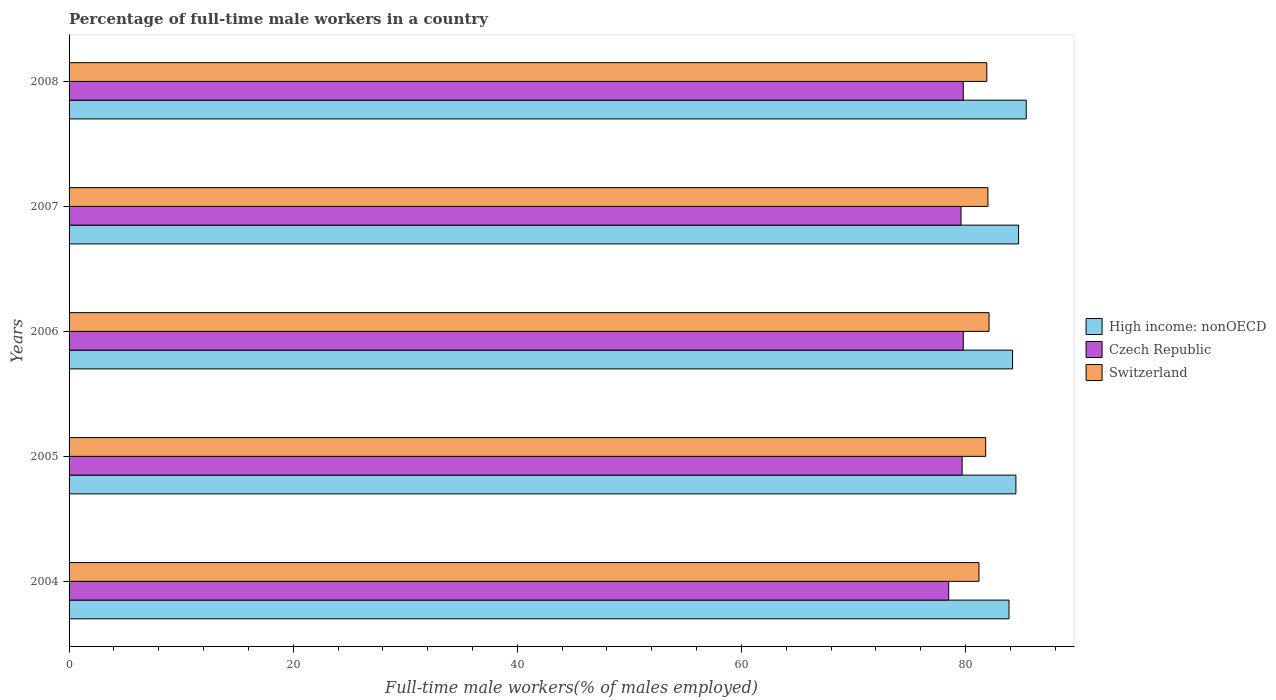How many different coloured bars are there?
Keep it short and to the point. 3. How many bars are there on the 4th tick from the top?
Your answer should be compact. 3. In how many cases, is the number of bars for a given year not equal to the number of legend labels?
Your answer should be very brief. 0. What is the percentage of full-time male workers in High income: nonOECD in 2005?
Your response must be concise. 84.5. Across all years, what is the maximum percentage of full-time male workers in High income: nonOECD?
Offer a very short reply. 85.42. Across all years, what is the minimum percentage of full-time male workers in Czech Republic?
Your response must be concise. 78.5. What is the total percentage of full-time male workers in Czech Republic in the graph?
Your answer should be compact. 397.4. What is the difference between the percentage of full-time male workers in High income: nonOECD in 2006 and that in 2007?
Provide a succinct answer. -0.54. What is the difference between the percentage of full-time male workers in High income: nonOECD in 2004 and the percentage of full-time male workers in Czech Republic in 2008?
Your answer should be very brief. 4.08. What is the average percentage of full-time male workers in Czech Republic per year?
Make the answer very short. 79.48. In the year 2004, what is the difference between the percentage of full-time male workers in Czech Republic and percentage of full-time male workers in High income: nonOECD?
Your answer should be compact. -5.38. In how many years, is the percentage of full-time male workers in Switzerland greater than 72 %?
Your response must be concise. 5. What is the ratio of the percentage of full-time male workers in Switzerland in 2004 to that in 2006?
Keep it short and to the point. 0.99. Is the difference between the percentage of full-time male workers in Czech Republic in 2004 and 2008 greater than the difference between the percentage of full-time male workers in High income: nonOECD in 2004 and 2008?
Give a very brief answer. Yes. What is the difference between the highest and the second highest percentage of full-time male workers in Switzerland?
Offer a terse response. 0.1. What is the difference between the highest and the lowest percentage of full-time male workers in Czech Republic?
Provide a short and direct response. 1.3. In how many years, is the percentage of full-time male workers in High income: nonOECD greater than the average percentage of full-time male workers in High income: nonOECD taken over all years?
Offer a terse response. 2. Is the sum of the percentage of full-time male workers in Czech Republic in 2004 and 2006 greater than the maximum percentage of full-time male workers in Switzerland across all years?
Provide a short and direct response. Yes. What does the 3rd bar from the top in 2005 represents?
Offer a terse response. High income: nonOECD. What does the 2nd bar from the bottom in 2005 represents?
Keep it short and to the point. Czech Republic. How many bars are there?
Provide a short and direct response. 15. What is the difference between two consecutive major ticks on the X-axis?
Your answer should be very brief. 20. Does the graph contain grids?
Offer a very short reply. No. Where does the legend appear in the graph?
Ensure brevity in your answer.  Center right. How are the legend labels stacked?
Provide a short and direct response. Vertical. What is the title of the graph?
Your answer should be very brief. Percentage of full-time male workers in a country. Does "Oman" appear as one of the legend labels in the graph?
Offer a terse response. No. What is the label or title of the X-axis?
Make the answer very short. Full-time male workers(% of males employed). What is the Full-time male workers(% of males employed) of High income: nonOECD in 2004?
Give a very brief answer. 83.88. What is the Full-time male workers(% of males employed) of Czech Republic in 2004?
Your answer should be compact. 78.5. What is the Full-time male workers(% of males employed) of Switzerland in 2004?
Offer a very short reply. 81.2. What is the Full-time male workers(% of males employed) in High income: nonOECD in 2005?
Your answer should be very brief. 84.5. What is the Full-time male workers(% of males employed) of Czech Republic in 2005?
Provide a succinct answer. 79.7. What is the Full-time male workers(% of males employed) of Switzerland in 2005?
Your answer should be very brief. 81.8. What is the Full-time male workers(% of males employed) in High income: nonOECD in 2006?
Offer a very short reply. 84.2. What is the Full-time male workers(% of males employed) of Czech Republic in 2006?
Keep it short and to the point. 79.8. What is the Full-time male workers(% of males employed) in Switzerland in 2006?
Keep it short and to the point. 82.1. What is the Full-time male workers(% of males employed) in High income: nonOECD in 2007?
Offer a very short reply. 84.74. What is the Full-time male workers(% of males employed) in Czech Republic in 2007?
Ensure brevity in your answer.  79.6. What is the Full-time male workers(% of males employed) of High income: nonOECD in 2008?
Provide a succinct answer. 85.42. What is the Full-time male workers(% of males employed) in Czech Republic in 2008?
Your response must be concise. 79.8. What is the Full-time male workers(% of males employed) of Switzerland in 2008?
Make the answer very short. 81.9. Across all years, what is the maximum Full-time male workers(% of males employed) in High income: nonOECD?
Ensure brevity in your answer.  85.42. Across all years, what is the maximum Full-time male workers(% of males employed) of Czech Republic?
Offer a very short reply. 79.8. Across all years, what is the maximum Full-time male workers(% of males employed) of Switzerland?
Offer a terse response. 82.1. Across all years, what is the minimum Full-time male workers(% of males employed) of High income: nonOECD?
Give a very brief answer. 83.88. Across all years, what is the minimum Full-time male workers(% of males employed) in Czech Republic?
Ensure brevity in your answer.  78.5. Across all years, what is the minimum Full-time male workers(% of males employed) of Switzerland?
Provide a short and direct response. 81.2. What is the total Full-time male workers(% of males employed) of High income: nonOECD in the graph?
Offer a very short reply. 422.74. What is the total Full-time male workers(% of males employed) in Czech Republic in the graph?
Offer a terse response. 397.4. What is the total Full-time male workers(% of males employed) of Switzerland in the graph?
Keep it short and to the point. 409. What is the difference between the Full-time male workers(% of males employed) of High income: nonOECD in 2004 and that in 2005?
Ensure brevity in your answer.  -0.61. What is the difference between the Full-time male workers(% of males employed) in Czech Republic in 2004 and that in 2005?
Provide a succinct answer. -1.2. What is the difference between the Full-time male workers(% of males employed) in Switzerland in 2004 and that in 2005?
Give a very brief answer. -0.6. What is the difference between the Full-time male workers(% of males employed) of High income: nonOECD in 2004 and that in 2006?
Offer a terse response. -0.32. What is the difference between the Full-time male workers(% of males employed) in High income: nonOECD in 2004 and that in 2007?
Your answer should be compact. -0.85. What is the difference between the Full-time male workers(% of males employed) of Czech Republic in 2004 and that in 2007?
Provide a succinct answer. -1.1. What is the difference between the Full-time male workers(% of males employed) of Switzerland in 2004 and that in 2007?
Your answer should be very brief. -0.8. What is the difference between the Full-time male workers(% of males employed) in High income: nonOECD in 2004 and that in 2008?
Give a very brief answer. -1.53. What is the difference between the Full-time male workers(% of males employed) in Czech Republic in 2004 and that in 2008?
Provide a succinct answer. -1.3. What is the difference between the Full-time male workers(% of males employed) in Switzerland in 2004 and that in 2008?
Offer a very short reply. -0.7. What is the difference between the Full-time male workers(% of males employed) of High income: nonOECD in 2005 and that in 2006?
Provide a succinct answer. 0.3. What is the difference between the Full-time male workers(% of males employed) in Czech Republic in 2005 and that in 2006?
Offer a very short reply. -0.1. What is the difference between the Full-time male workers(% of males employed) in High income: nonOECD in 2005 and that in 2007?
Give a very brief answer. -0.24. What is the difference between the Full-time male workers(% of males employed) of Switzerland in 2005 and that in 2007?
Provide a short and direct response. -0.2. What is the difference between the Full-time male workers(% of males employed) of High income: nonOECD in 2005 and that in 2008?
Ensure brevity in your answer.  -0.92. What is the difference between the Full-time male workers(% of males employed) in Czech Republic in 2005 and that in 2008?
Provide a succinct answer. -0.1. What is the difference between the Full-time male workers(% of males employed) in Switzerland in 2005 and that in 2008?
Your answer should be compact. -0.1. What is the difference between the Full-time male workers(% of males employed) of High income: nonOECD in 2006 and that in 2007?
Keep it short and to the point. -0.54. What is the difference between the Full-time male workers(% of males employed) of Czech Republic in 2006 and that in 2007?
Provide a succinct answer. 0.2. What is the difference between the Full-time male workers(% of males employed) in High income: nonOECD in 2006 and that in 2008?
Give a very brief answer. -1.22. What is the difference between the Full-time male workers(% of males employed) of High income: nonOECD in 2007 and that in 2008?
Offer a very short reply. -0.68. What is the difference between the Full-time male workers(% of males employed) of Switzerland in 2007 and that in 2008?
Provide a succinct answer. 0.1. What is the difference between the Full-time male workers(% of males employed) of High income: nonOECD in 2004 and the Full-time male workers(% of males employed) of Czech Republic in 2005?
Your answer should be compact. 4.18. What is the difference between the Full-time male workers(% of males employed) in High income: nonOECD in 2004 and the Full-time male workers(% of males employed) in Switzerland in 2005?
Your response must be concise. 2.08. What is the difference between the Full-time male workers(% of males employed) in High income: nonOECD in 2004 and the Full-time male workers(% of males employed) in Czech Republic in 2006?
Your response must be concise. 4.08. What is the difference between the Full-time male workers(% of males employed) in High income: nonOECD in 2004 and the Full-time male workers(% of males employed) in Switzerland in 2006?
Keep it short and to the point. 1.78. What is the difference between the Full-time male workers(% of males employed) in High income: nonOECD in 2004 and the Full-time male workers(% of males employed) in Czech Republic in 2007?
Make the answer very short. 4.28. What is the difference between the Full-time male workers(% of males employed) in High income: nonOECD in 2004 and the Full-time male workers(% of males employed) in Switzerland in 2007?
Your response must be concise. 1.88. What is the difference between the Full-time male workers(% of males employed) of High income: nonOECD in 2004 and the Full-time male workers(% of males employed) of Czech Republic in 2008?
Provide a succinct answer. 4.08. What is the difference between the Full-time male workers(% of males employed) in High income: nonOECD in 2004 and the Full-time male workers(% of males employed) in Switzerland in 2008?
Provide a short and direct response. 1.98. What is the difference between the Full-time male workers(% of males employed) of Czech Republic in 2004 and the Full-time male workers(% of males employed) of Switzerland in 2008?
Your response must be concise. -3.4. What is the difference between the Full-time male workers(% of males employed) of High income: nonOECD in 2005 and the Full-time male workers(% of males employed) of Czech Republic in 2006?
Keep it short and to the point. 4.7. What is the difference between the Full-time male workers(% of males employed) of High income: nonOECD in 2005 and the Full-time male workers(% of males employed) of Switzerland in 2006?
Provide a short and direct response. 2.4. What is the difference between the Full-time male workers(% of males employed) of Czech Republic in 2005 and the Full-time male workers(% of males employed) of Switzerland in 2006?
Your response must be concise. -2.4. What is the difference between the Full-time male workers(% of males employed) in High income: nonOECD in 2005 and the Full-time male workers(% of males employed) in Czech Republic in 2007?
Make the answer very short. 4.9. What is the difference between the Full-time male workers(% of males employed) of High income: nonOECD in 2005 and the Full-time male workers(% of males employed) of Switzerland in 2007?
Provide a short and direct response. 2.5. What is the difference between the Full-time male workers(% of males employed) of Czech Republic in 2005 and the Full-time male workers(% of males employed) of Switzerland in 2007?
Give a very brief answer. -2.3. What is the difference between the Full-time male workers(% of males employed) of High income: nonOECD in 2005 and the Full-time male workers(% of males employed) of Czech Republic in 2008?
Provide a succinct answer. 4.7. What is the difference between the Full-time male workers(% of males employed) in High income: nonOECD in 2005 and the Full-time male workers(% of males employed) in Switzerland in 2008?
Provide a short and direct response. 2.6. What is the difference between the Full-time male workers(% of males employed) of High income: nonOECD in 2006 and the Full-time male workers(% of males employed) of Czech Republic in 2007?
Your answer should be compact. 4.6. What is the difference between the Full-time male workers(% of males employed) of High income: nonOECD in 2006 and the Full-time male workers(% of males employed) of Switzerland in 2007?
Offer a terse response. 2.2. What is the difference between the Full-time male workers(% of males employed) in High income: nonOECD in 2006 and the Full-time male workers(% of males employed) in Czech Republic in 2008?
Your answer should be very brief. 4.4. What is the difference between the Full-time male workers(% of males employed) in High income: nonOECD in 2006 and the Full-time male workers(% of males employed) in Switzerland in 2008?
Your answer should be very brief. 2.3. What is the difference between the Full-time male workers(% of males employed) of High income: nonOECD in 2007 and the Full-time male workers(% of males employed) of Czech Republic in 2008?
Offer a very short reply. 4.94. What is the difference between the Full-time male workers(% of males employed) in High income: nonOECD in 2007 and the Full-time male workers(% of males employed) in Switzerland in 2008?
Make the answer very short. 2.84. What is the difference between the Full-time male workers(% of males employed) in Czech Republic in 2007 and the Full-time male workers(% of males employed) in Switzerland in 2008?
Give a very brief answer. -2.3. What is the average Full-time male workers(% of males employed) in High income: nonOECD per year?
Ensure brevity in your answer.  84.55. What is the average Full-time male workers(% of males employed) of Czech Republic per year?
Offer a very short reply. 79.48. What is the average Full-time male workers(% of males employed) in Switzerland per year?
Your response must be concise. 81.8. In the year 2004, what is the difference between the Full-time male workers(% of males employed) of High income: nonOECD and Full-time male workers(% of males employed) of Czech Republic?
Your response must be concise. 5.38. In the year 2004, what is the difference between the Full-time male workers(% of males employed) in High income: nonOECD and Full-time male workers(% of males employed) in Switzerland?
Ensure brevity in your answer.  2.68. In the year 2005, what is the difference between the Full-time male workers(% of males employed) of High income: nonOECD and Full-time male workers(% of males employed) of Czech Republic?
Your answer should be compact. 4.8. In the year 2005, what is the difference between the Full-time male workers(% of males employed) in High income: nonOECD and Full-time male workers(% of males employed) in Switzerland?
Ensure brevity in your answer.  2.7. In the year 2005, what is the difference between the Full-time male workers(% of males employed) of Czech Republic and Full-time male workers(% of males employed) of Switzerland?
Offer a terse response. -2.1. In the year 2006, what is the difference between the Full-time male workers(% of males employed) of High income: nonOECD and Full-time male workers(% of males employed) of Czech Republic?
Your answer should be very brief. 4.4. In the year 2006, what is the difference between the Full-time male workers(% of males employed) in High income: nonOECD and Full-time male workers(% of males employed) in Switzerland?
Your response must be concise. 2.1. In the year 2006, what is the difference between the Full-time male workers(% of males employed) of Czech Republic and Full-time male workers(% of males employed) of Switzerland?
Your response must be concise. -2.3. In the year 2007, what is the difference between the Full-time male workers(% of males employed) of High income: nonOECD and Full-time male workers(% of males employed) of Czech Republic?
Ensure brevity in your answer.  5.14. In the year 2007, what is the difference between the Full-time male workers(% of males employed) of High income: nonOECD and Full-time male workers(% of males employed) of Switzerland?
Keep it short and to the point. 2.74. In the year 2007, what is the difference between the Full-time male workers(% of males employed) in Czech Republic and Full-time male workers(% of males employed) in Switzerland?
Offer a very short reply. -2.4. In the year 2008, what is the difference between the Full-time male workers(% of males employed) in High income: nonOECD and Full-time male workers(% of males employed) in Czech Republic?
Offer a very short reply. 5.62. In the year 2008, what is the difference between the Full-time male workers(% of males employed) of High income: nonOECD and Full-time male workers(% of males employed) of Switzerland?
Keep it short and to the point. 3.52. What is the ratio of the Full-time male workers(% of males employed) in High income: nonOECD in 2004 to that in 2005?
Provide a succinct answer. 0.99. What is the ratio of the Full-time male workers(% of males employed) of Czech Republic in 2004 to that in 2005?
Your response must be concise. 0.98. What is the ratio of the Full-time male workers(% of males employed) in High income: nonOECD in 2004 to that in 2006?
Offer a very short reply. 1. What is the ratio of the Full-time male workers(% of males employed) of Czech Republic in 2004 to that in 2006?
Offer a terse response. 0.98. What is the ratio of the Full-time male workers(% of males employed) of Switzerland in 2004 to that in 2006?
Your answer should be very brief. 0.99. What is the ratio of the Full-time male workers(% of males employed) of High income: nonOECD in 2004 to that in 2007?
Make the answer very short. 0.99. What is the ratio of the Full-time male workers(% of males employed) of Czech Republic in 2004 to that in 2007?
Give a very brief answer. 0.99. What is the ratio of the Full-time male workers(% of males employed) in Switzerland in 2004 to that in 2007?
Ensure brevity in your answer.  0.99. What is the ratio of the Full-time male workers(% of males employed) in High income: nonOECD in 2004 to that in 2008?
Your answer should be compact. 0.98. What is the ratio of the Full-time male workers(% of males employed) of Czech Republic in 2004 to that in 2008?
Make the answer very short. 0.98. What is the ratio of the Full-time male workers(% of males employed) in Switzerland in 2004 to that in 2008?
Provide a short and direct response. 0.99. What is the ratio of the Full-time male workers(% of males employed) of Czech Republic in 2005 to that in 2007?
Offer a very short reply. 1. What is the ratio of the Full-time male workers(% of males employed) in Switzerland in 2005 to that in 2007?
Ensure brevity in your answer.  1. What is the ratio of the Full-time male workers(% of males employed) of High income: nonOECD in 2005 to that in 2008?
Give a very brief answer. 0.99. What is the ratio of the Full-time male workers(% of males employed) of Czech Republic in 2005 to that in 2008?
Give a very brief answer. 1. What is the ratio of the Full-time male workers(% of males employed) in Switzerland in 2005 to that in 2008?
Give a very brief answer. 1. What is the ratio of the Full-time male workers(% of males employed) of High income: nonOECD in 2006 to that in 2007?
Offer a very short reply. 0.99. What is the ratio of the Full-time male workers(% of males employed) in Switzerland in 2006 to that in 2007?
Your response must be concise. 1. What is the ratio of the Full-time male workers(% of males employed) of High income: nonOECD in 2006 to that in 2008?
Provide a short and direct response. 0.99. What is the ratio of the Full-time male workers(% of males employed) of Czech Republic in 2006 to that in 2008?
Ensure brevity in your answer.  1. What is the ratio of the Full-time male workers(% of males employed) in Switzerland in 2006 to that in 2008?
Your answer should be very brief. 1. What is the ratio of the Full-time male workers(% of males employed) of Switzerland in 2007 to that in 2008?
Make the answer very short. 1. What is the difference between the highest and the second highest Full-time male workers(% of males employed) of High income: nonOECD?
Your answer should be very brief. 0.68. What is the difference between the highest and the second highest Full-time male workers(% of males employed) of Czech Republic?
Offer a terse response. 0. What is the difference between the highest and the second highest Full-time male workers(% of males employed) of Switzerland?
Your answer should be very brief. 0.1. What is the difference between the highest and the lowest Full-time male workers(% of males employed) in High income: nonOECD?
Keep it short and to the point. 1.53. What is the difference between the highest and the lowest Full-time male workers(% of males employed) of Czech Republic?
Offer a terse response. 1.3. What is the difference between the highest and the lowest Full-time male workers(% of males employed) in Switzerland?
Your response must be concise. 0.9. 